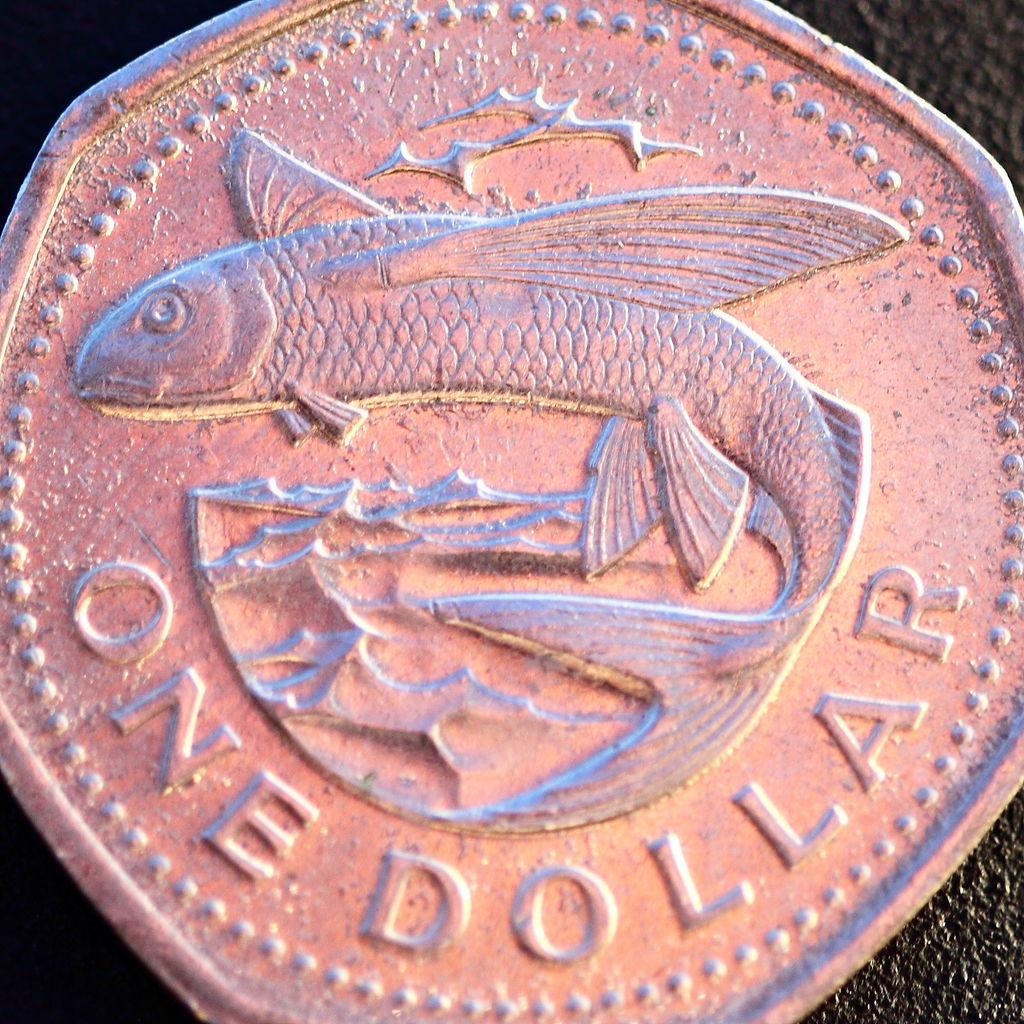<image>
Render a clear and concise summary of the photo. A one dollar coin with a flying fish on it. 